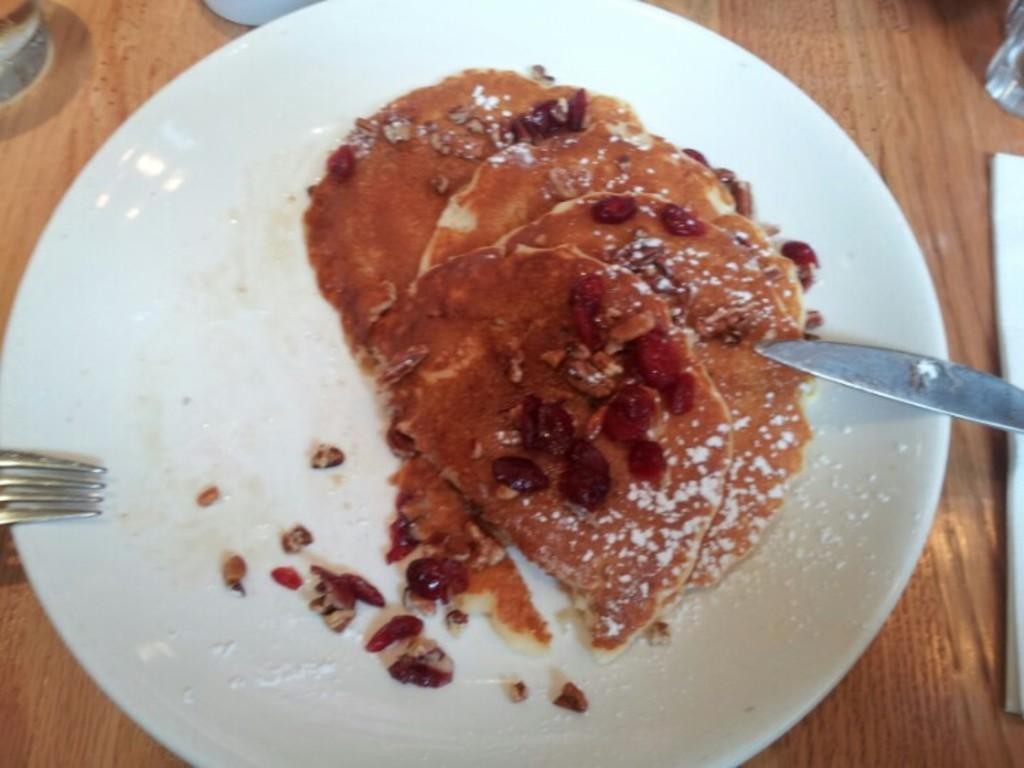What is on the plate in the image? There is a food item on a plate in the image. What utensils are present near the plate? There is a knife and a fork beside the plate. Where is the plate located? The plate is on top of a table. What country is depicted in the image? There is no country depicted in the image; it features a plate with a food item and utensils on a table. What time of day is it in the image? The time of day is not specified in the image; it could be any time of day. 